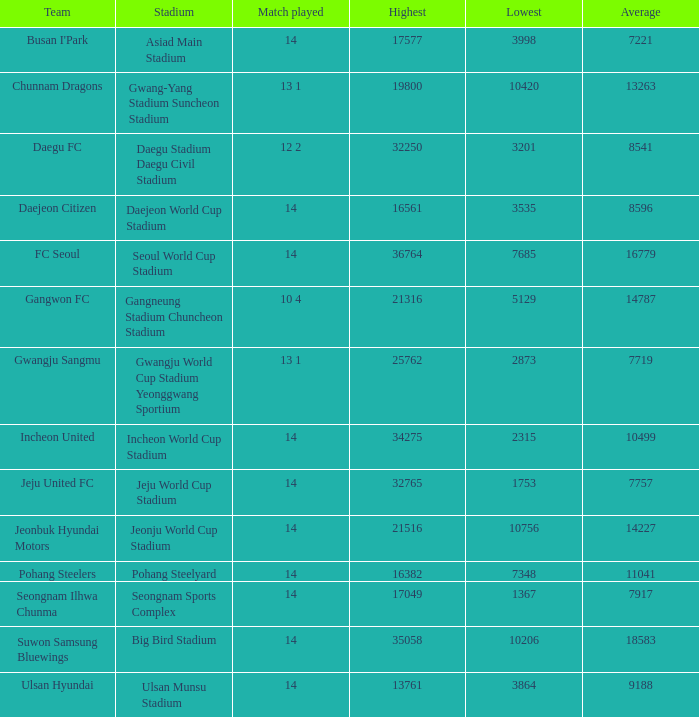How many games played have the maximum as 32250? 12 2. 